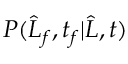Convert formula to latex. <formula><loc_0><loc_0><loc_500><loc_500>P ( \widehat { L } _ { f } , t _ { f } | \widehat { L } , t )</formula> 